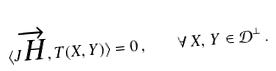Convert formula to latex. <formula><loc_0><loc_0><loc_500><loc_500>\langle J \overrightarrow { H } , T ( X , Y ) \rangle = 0 \, , \quad \forall \, X , \, Y \in \mathcal { D } ^ { \perp } \, .</formula> 